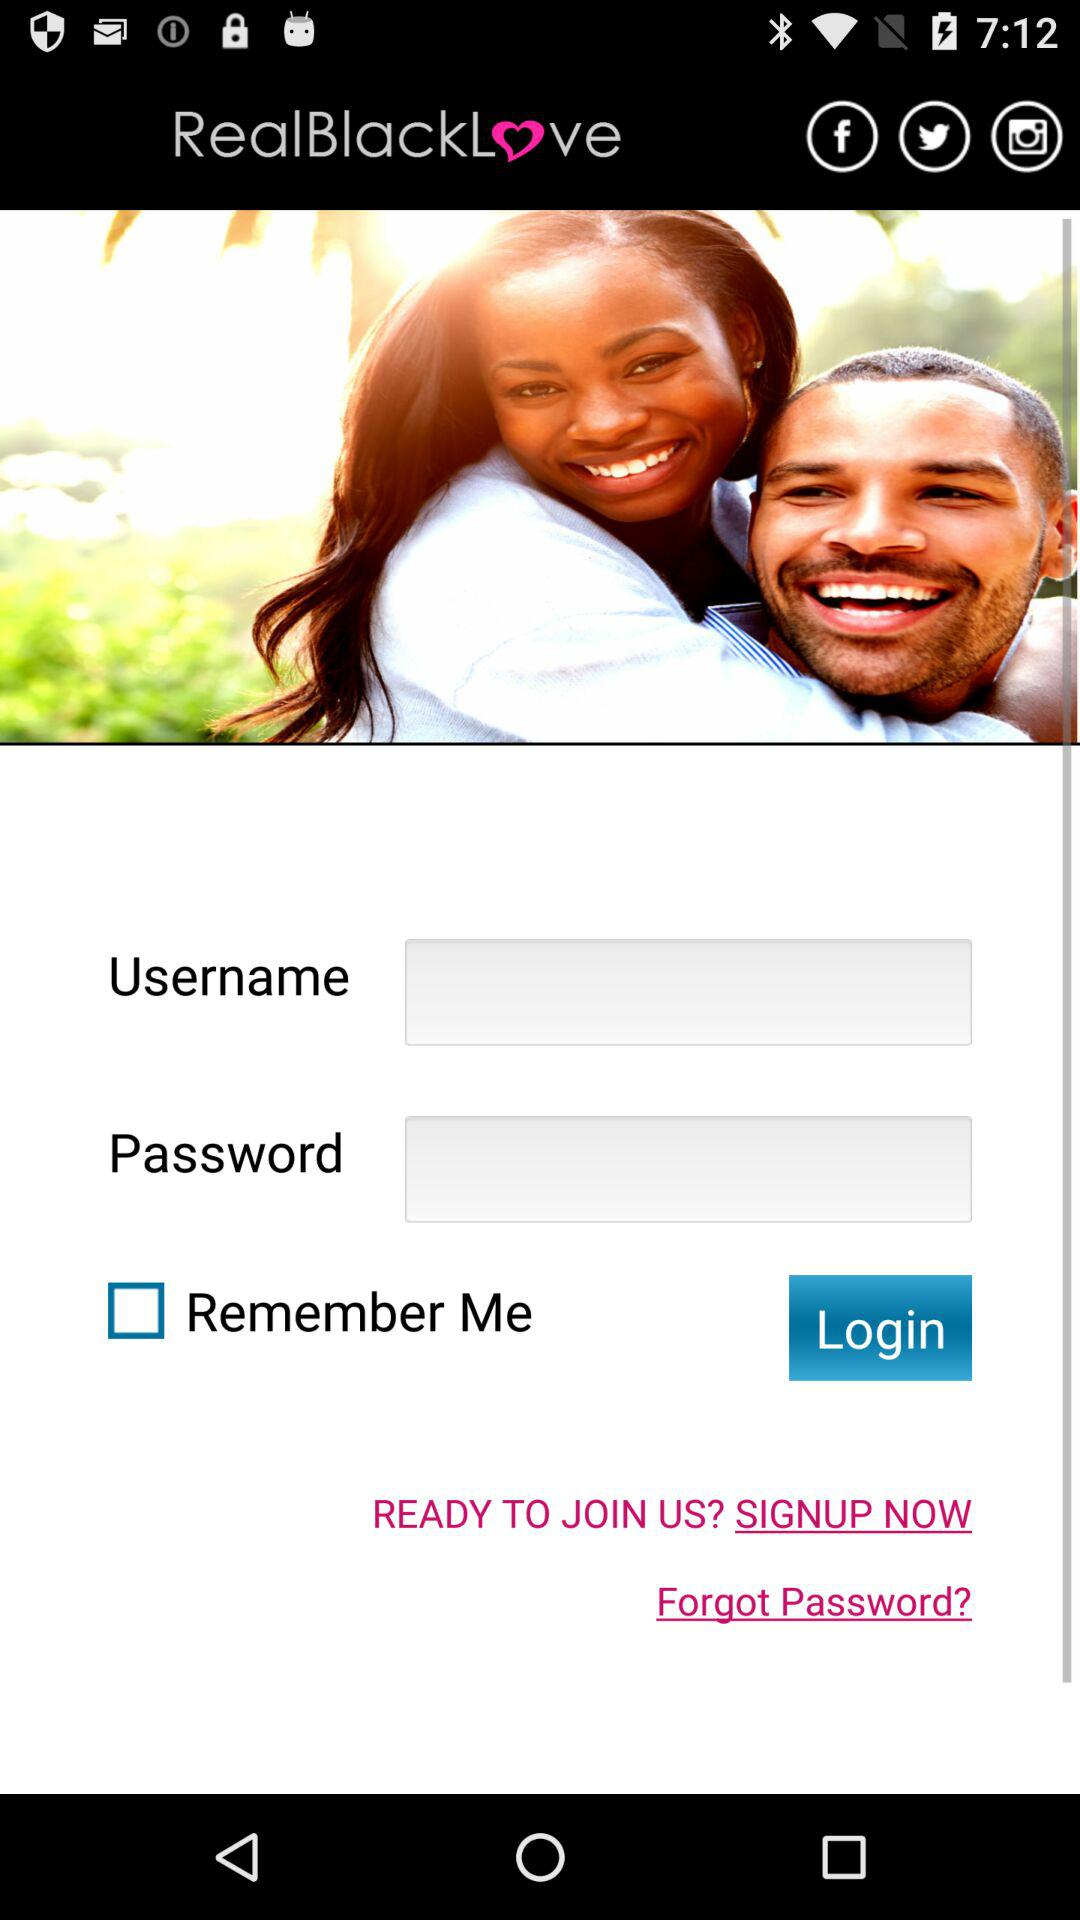What are the details needed to log in? The details needed to log in are "Username" and "Password". 